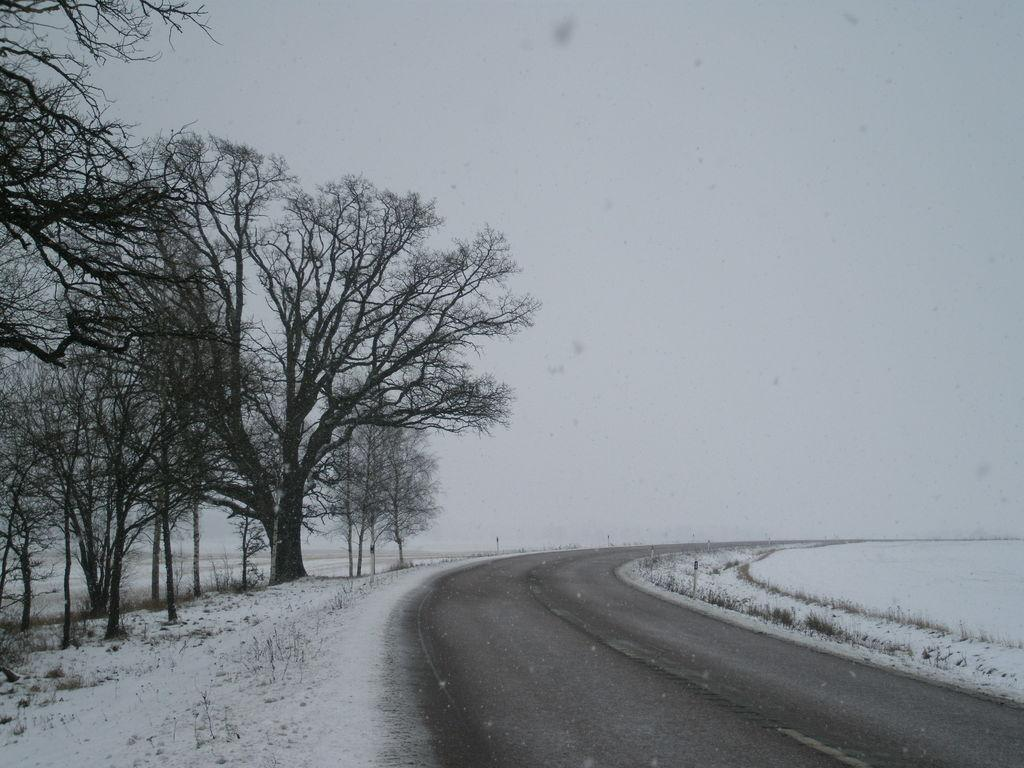What can be seen on the left side of the image? There are trees, plants, and snow on the left side of the image. What is in the center of the image? There is a road in the center of the image. What is present on the right side of the image? There is snow on the right side of the image. How would you describe the sky in the image? The sky is cloudy in the image. Can you see a bee buzzing around the plants on the left side of the image? There is no bee present in the image. Is there a ball rolling down the road in the center of the image? There is no ball present in the image. 